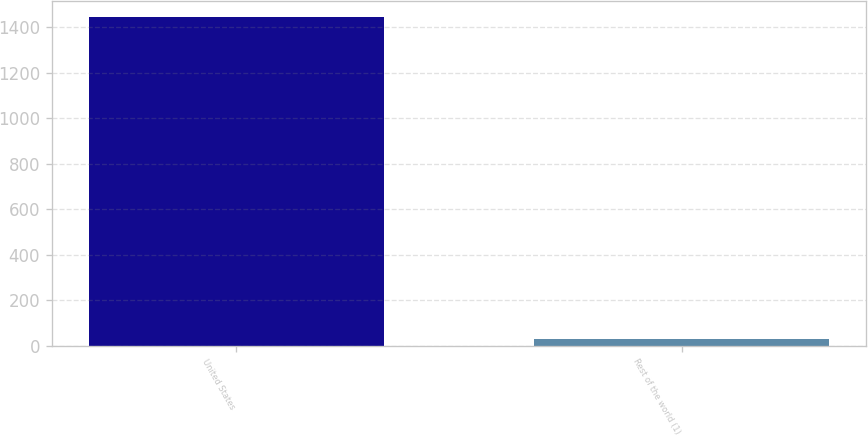<chart> <loc_0><loc_0><loc_500><loc_500><bar_chart><fcel>United States<fcel>Rest of the world (1)<nl><fcel>1444<fcel>31<nl></chart> 